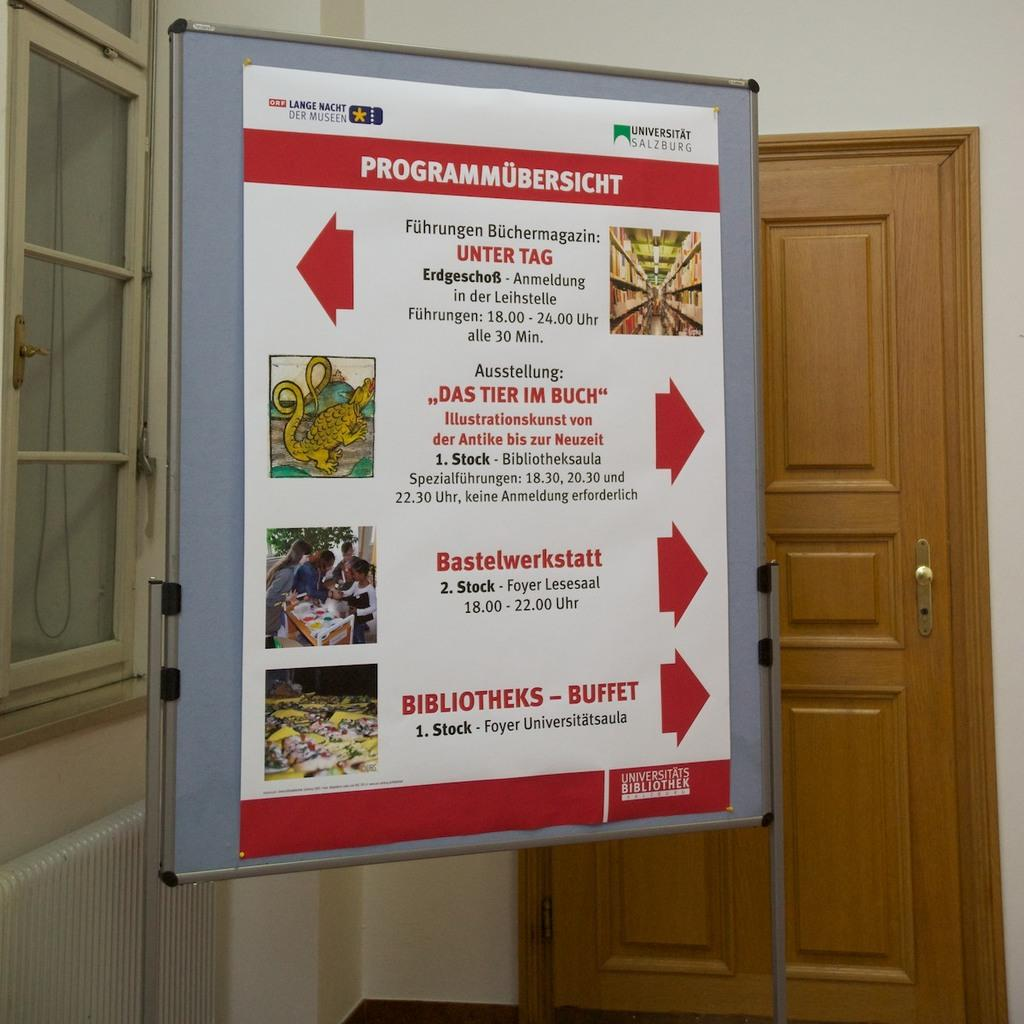Provide a one-sentence caption for the provided image. Programmubersicht sign for the universitats bibliothek on a board in a room. 